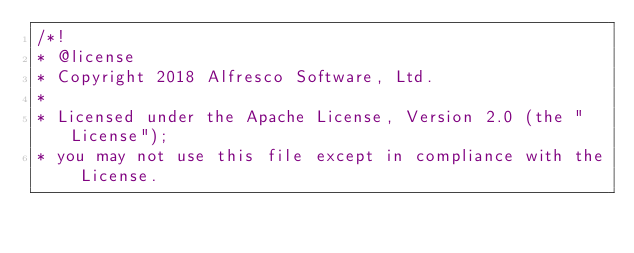<code> <loc_0><loc_0><loc_500><loc_500><_TypeScript_>/*!
* @license
* Copyright 2018 Alfresco Software, Ltd.
*
* Licensed under the Apache License, Version 2.0 (the "License");
* you may not use this file except in compliance with the License.</code> 